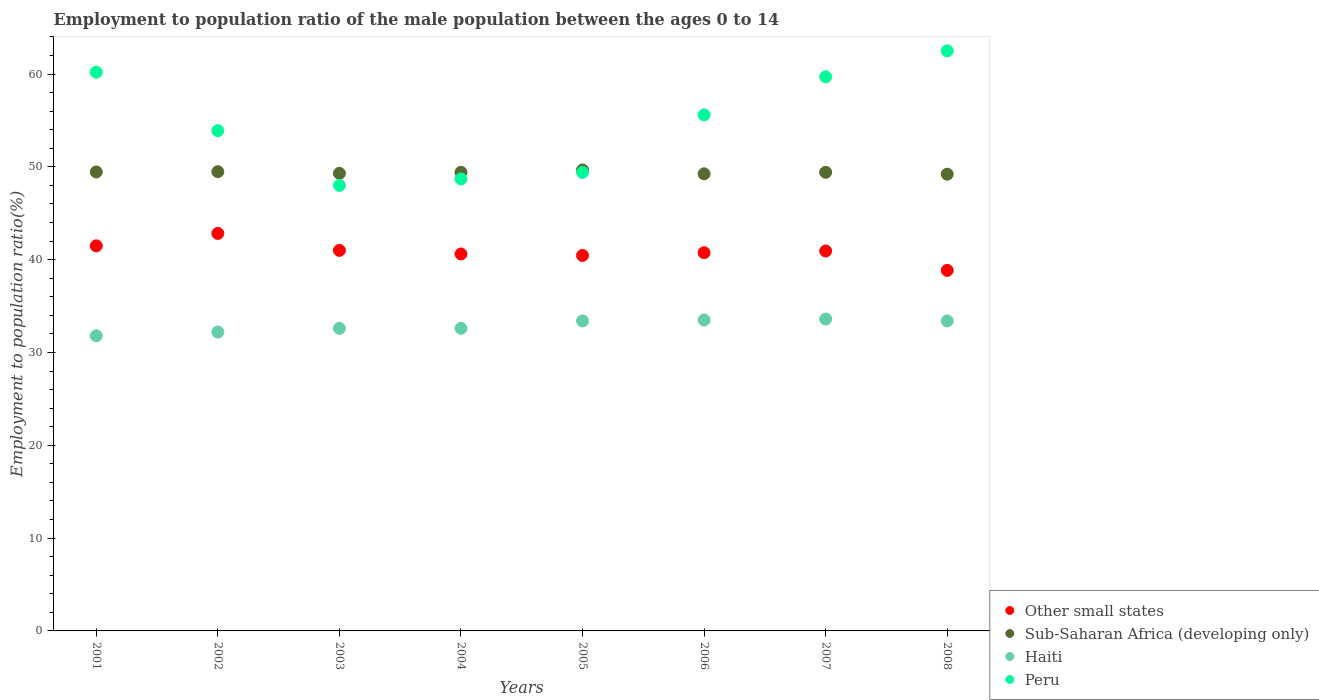What is the employment to population ratio in Other small states in 2008?
Your response must be concise. 38.85. Across all years, what is the maximum employment to population ratio in Haiti?
Your response must be concise. 33.6. Across all years, what is the minimum employment to population ratio in Haiti?
Ensure brevity in your answer.  31.8. In which year was the employment to population ratio in Haiti minimum?
Give a very brief answer. 2001. What is the total employment to population ratio in Haiti in the graph?
Provide a short and direct response. 263.1. What is the difference between the employment to population ratio in Peru in 2003 and that in 2004?
Ensure brevity in your answer.  -0.7. What is the difference between the employment to population ratio in Peru in 2006 and the employment to population ratio in Sub-Saharan Africa (developing only) in 2008?
Make the answer very short. 6.39. What is the average employment to population ratio in Other small states per year?
Provide a succinct answer. 40.86. In the year 2002, what is the difference between the employment to population ratio in Other small states and employment to population ratio in Peru?
Provide a succinct answer. -11.07. In how many years, is the employment to population ratio in Haiti greater than 48 %?
Make the answer very short. 0. Is the employment to population ratio in Haiti in 2007 less than that in 2008?
Give a very brief answer. No. Is the difference between the employment to population ratio in Other small states in 2004 and 2007 greater than the difference between the employment to population ratio in Peru in 2004 and 2007?
Ensure brevity in your answer.  Yes. What is the difference between the highest and the second highest employment to population ratio in Haiti?
Provide a succinct answer. 0.1. What is the difference between the highest and the lowest employment to population ratio in Other small states?
Your answer should be compact. 3.98. In how many years, is the employment to population ratio in Other small states greater than the average employment to population ratio in Other small states taken over all years?
Offer a very short reply. 4. Is it the case that in every year, the sum of the employment to population ratio in Haiti and employment to population ratio in Other small states  is greater than the employment to population ratio in Peru?
Your answer should be compact. Yes. Is the employment to population ratio in Sub-Saharan Africa (developing only) strictly less than the employment to population ratio in Peru over the years?
Give a very brief answer. No. How many years are there in the graph?
Your answer should be very brief. 8. What is the difference between two consecutive major ticks on the Y-axis?
Your answer should be compact. 10. Does the graph contain grids?
Your response must be concise. No. Where does the legend appear in the graph?
Offer a terse response. Bottom right. How are the legend labels stacked?
Offer a very short reply. Vertical. What is the title of the graph?
Give a very brief answer. Employment to population ratio of the male population between the ages 0 to 14. What is the Employment to population ratio(%) in Other small states in 2001?
Keep it short and to the point. 41.49. What is the Employment to population ratio(%) in Sub-Saharan Africa (developing only) in 2001?
Offer a very short reply. 49.45. What is the Employment to population ratio(%) in Haiti in 2001?
Provide a succinct answer. 31.8. What is the Employment to population ratio(%) of Peru in 2001?
Provide a short and direct response. 60.2. What is the Employment to population ratio(%) in Other small states in 2002?
Provide a short and direct response. 42.83. What is the Employment to population ratio(%) in Sub-Saharan Africa (developing only) in 2002?
Provide a short and direct response. 49.48. What is the Employment to population ratio(%) in Haiti in 2002?
Offer a very short reply. 32.2. What is the Employment to population ratio(%) of Peru in 2002?
Give a very brief answer. 53.9. What is the Employment to population ratio(%) of Other small states in 2003?
Provide a succinct answer. 41. What is the Employment to population ratio(%) in Sub-Saharan Africa (developing only) in 2003?
Offer a terse response. 49.3. What is the Employment to population ratio(%) in Haiti in 2003?
Your answer should be compact. 32.6. What is the Employment to population ratio(%) of Peru in 2003?
Your response must be concise. 48. What is the Employment to population ratio(%) of Other small states in 2004?
Your answer should be very brief. 40.61. What is the Employment to population ratio(%) in Sub-Saharan Africa (developing only) in 2004?
Offer a very short reply. 49.41. What is the Employment to population ratio(%) of Haiti in 2004?
Your answer should be very brief. 32.6. What is the Employment to population ratio(%) of Peru in 2004?
Offer a very short reply. 48.7. What is the Employment to population ratio(%) in Other small states in 2005?
Keep it short and to the point. 40.45. What is the Employment to population ratio(%) of Sub-Saharan Africa (developing only) in 2005?
Keep it short and to the point. 49.66. What is the Employment to population ratio(%) of Haiti in 2005?
Give a very brief answer. 33.4. What is the Employment to population ratio(%) of Peru in 2005?
Your response must be concise. 49.4. What is the Employment to population ratio(%) of Other small states in 2006?
Ensure brevity in your answer.  40.75. What is the Employment to population ratio(%) in Sub-Saharan Africa (developing only) in 2006?
Provide a succinct answer. 49.25. What is the Employment to population ratio(%) of Haiti in 2006?
Ensure brevity in your answer.  33.5. What is the Employment to population ratio(%) of Peru in 2006?
Your response must be concise. 55.6. What is the Employment to population ratio(%) of Other small states in 2007?
Make the answer very short. 40.93. What is the Employment to population ratio(%) in Sub-Saharan Africa (developing only) in 2007?
Your answer should be compact. 49.41. What is the Employment to population ratio(%) of Haiti in 2007?
Your response must be concise. 33.6. What is the Employment to population ratio(%) in Peru in 2007?
Give a very brief answer. 59.7. What is the Employment to population ratio(%) in Other small states in 2008?
Make the answer very short. 38.85. What is the Employment to population ratio(%) of Sub-Saharan Africa (developing only) in 2008?
Offer a terse response. 49.21. What is the Employment to population ratio(%) in Haiti in 2008?
Offer a terse response. 33.4. What is the Employment to population ratio(%) of Peru in 2008?
Provide a succinct answer. 62.5. Across all years, what is the maximum Employment to population ratio(%) in Other small states?
Make the answer very short. 42.83. Across all years, what is the maximum Employment to population ratio(%) in Sub-Saharan Africa (developing only)?
Make the answer very short. 49.66. Across all years, what is the maximum Employment to population ratio(%) of Haiti?
Offer a terse response. 33.6. Across all years, what is the maximum Employment to population ratio(%) of Peru?
Provide a short and direct response. 62.5. Across all years, what is the minimum Employment to population ratio(%) in Other small states?
Keep it short and to the point. 38.85. Across all years, what is the minimum Employment to population ratio(%) of Sub-Saharan Africa (developing only)?
Give a very brief answer. 49.21. Across all years, what is the minimum Employment to population ratio(%) of Haiti?
Your response must be concise. 31.8. Across all years, what is the minimum Employment to population ratio(%) of Peru?
Provide a succinct answer. 48. What is the total Employment to population ratio(%) in Other small states in the graph?
Keep it short and to the point. 326.91. What is the total Employment to population ratio(%) of Sub-Saharan Africa (developing only) in the graph?
Keep it short and to the point. 395.16. What is the total Employment to population ratio(%) of Haiti in the graph?
Make the answer very short. 263.1. What is the total Employment to population ratio(%) of Peru in the graph?
Offer a terse response. 438. What is the difference between the Employment to population ratio(%) in Other small states in 2001 and that in 2002?
Give a very brief answer. -1.34. What is the difference between the Employment to population ratio(%) of Sub-Saharan Africa (developing only) in 2001 and that in 2002?
Offer a very short reply. -0.03. What is the difference between the Employment to population ratio(%) of Haiti in 2001 and that in 2002?
Keep it short and to the point. -0.4. What is the difference between the Employment to population ratio(%) in Peru in 2001 and that in 2002?
Ensure brevity in your answer.  6.3. What is the difference between the Employment to population ratio(%) in Other small states in 2001 and that in 2003?
Give a very brief answer. 0.49. What is the difference between the Employment to population ratio(%) of Sub-Saharan Africa (developing only) in 2001 and that in 2003?
Offer a very short reply. 0.15. What is the difference between the Employment to population ratio(%) in Peru in 2001 and that in 2003?
Keep it short and to the point. 12.2. What is the difference between the Employment to population ratio(%) in Other small states in 2001 and that in 2004?
Give a very brief answer. 0.87. What is the difference between the Employment to population ratio(%) in Sub-Saharan Africa (developing only) in 2001 and that in 2004?
Offer a very short reply. 0.04. What is the difference between the Employment to population ratio(%) of Haiti in 2001 and that in 2004?
Make the answer very short. -0.8. What is the difference between the Employment to population ratio(%) of Peru in 2001 and that in 2004?
Your answer should be very brief. 11.5. What is the difference between the Employment to population ratio(%) in Other small states in 2001 and that in 2005?
Offer a very short reply. 1.03. What is the difference between the Employment to population ratio(%) of Sub-Saharan Africa (developing only) in 2001 and that in 2005?
Your answer should be very brief. -0.21. What is the difference between the Employment to population ratio(%) in Peru in 2001 and that in 2005?
Ensure brevity in your answer.  10.8. What is the difference between the Employment to population ratio(%) in Other small states in 2001 and that in 2006?
Provide a short and direct response. 0.74. What is the difference between the Employment to population ratio(%) of Sub-Saharan Africa (developing only) in 2001 and that in 2006?
Your answer should be very brief. 0.2. What is the difference between the Employment to population ratio(%) of Other small states in 2001 and that in 2007?
Provide a short and direct response. 0.55. What is the difference between the Employment to population ratio(%) in Sub-Saharan Africa (developing only) in 2001 and that in 2007?
Provide a short and direct response. 0.04. What is the difference between the Employment to population ratio(%) in Haiti in 2001 and that in 2007?
Keep it short and to the point. -1.8. What is the difference between the Employment to population ratio(%) of Other small states in 2001 and that in 2008?
Your answer should be very brief. 2.64. What is the difference between the Employment to population ratio(%) in Sub-Saharan Africa (developing only) in 2001 and that in 2008?
Keep it short and to the point. 0.24. What is the difference between the Employment to population ratio(%) of Haiti in 2001 and that in 2008?
Give a very brief answer. -1.6. What is the difference between the Employment to population ratio(%) in Peru in 2001 and that in 2008?
Your answer should be very brief. -2.3. What is the difference between the Employment to population ratio(%) in Other small states in 2002 and that in 2003?
Keep it short and to the point. 1.83. What is the difference between the Employment to population ratio(%) in Sub-Saharan Africa (developing only) in 2002 and that in 2003?
Your response must be concise. 0.18. What is the difference between the Employment to population ratio(%) in Other small states in 2002 and that in 2004?
Your answer should be very brief. 2.21. What is the difference between the Employment to population ratio(%) in Sub-Saharan Africa (developing only) in 2002 and that in 2004?
Provide a short and direct response. 0.07. What is the difference between the Employment to population ratio(%) in Haiti in 2002 and that in 2004?
Provide a succinct answer. -0.4. What is the difference between the Employment to population ratio(%) in Other small states in 2002 and that in 2005?
Provide a short and direct response. 2.37. What is the difference between the Employment to population ratio(%) of Sub-Saharan Africa (developing only) in 2002 and that in 2005?
Your answer should be very brief. -0.18. What is the difference between the Employment to population ratio(%) in Other small states in 2002 and that in 2006?
Your answer should be compact. 2.08. What is the difference between the Employment to population ratio(%) of Sub-Saharan Africa (developing only) in 2002 and that in 2006?
Ensure brevity in your answer.  0.23. What is the difference between the Employment to population ratio(%) of Haiti in 2002 and that in 2006?
Ensure brevity in your answer.  -1.3. What is the difference between the Employment to population ratio(%) of Other small states in 2002 and that in 2007?
Make the answer very short. 1.89. What is the difference between the Employment to population ratio(%) of Sub-Saharan Africa (developing only) in 2002 and that in 2007?
Your answer should be very brief. 0.07. What is the difference between the Employment to population ratio(%) of Other small states in 2002 and that in 2008?
Keep it short and to the point. 3.98. What is the difference between the Employment to population ratio(%) of Sub-Saharan Africa (developing only) in 2002 and that in 2008?
Offer a very short reply. 0.27. What is the difference between the Employment to population ratio(%) of Haiti in 2002 and that in 2008?
Your answer should be compact. -1.2. What is the difference between the Employment to population ratio(%) in Peru in 2002 and that in 2008?
Your answer should be compact. -8.6. What is the difference between the Employment to population ratio(%) in Other small states in 2003 and that in 2004?
Offer a very short reply. 0.38. What is the difference between the Employment to population ratio(%) of Sub-Saharan Africa (developing only) in 2003 and that in 2004?
Make the answer very short. -0.11. What is the difference between the Employment to population ratio(%) in Other small states in 2003 and that in 2005?
Ensure brevity in your answer.  0.54. What is the difference between the Employment to population ratio(%) of Sub-Saharan Africa (developing only) in 2003 and that in 2005?
Offer a terse response. -0.36. What is the difference between the Employment to population ratio(%) of Other small states in 2003 and that in 2006?
Offer a very short reply. 0.25. What is the difference between the Employment to population ratio(%) in Sub-Saharan Africa (developing only) in 2003 and that in 2006?
Provide a short and direct response. 0.05. What is the difference between the Employment to population ratio(%) of Other small states in 2003 and that in 2007?
Offer a terse response. 0.06. What is the difference between the Employment to population ratio(%) of Sub-Saharan Africa (developing only) in 2003 and that in 2007?
Provide a short and direct response. -0.11. What is the difference between the Employment to population ratio(%) of Other small states in 2003 and that in 2008?
Your answer should be very brief. 2.15. What is the difference between the Employment to population ratio(%) of Sub-Saharan Africa (developing only) in 2003 and that in 2008?
Your answer should be compact. 0.09. What is the difference between the Employment to population ratio(%) of Peru in 2003 and that in 2008?
Provide a succinct answer. -14.5. What is the difference between the Employment to population ratio(%) of Other small states in 2004 and that in 2005?
Make the answer very short. 0.16. What is the difference between the Employment to population ratio(%) in Sub-Saharan Africa (developing only) in 2004 and that in 2005?
Provide a succinct answer. -0.25. What is the difference between the Employment to population ratio(%) in Peru in 2004 and that in 2005?
Your response must be concise. -0.7. What is the difference between the Employment to population ratio(%) of Other small states in 2004 and that in 2006?
Offer a very short reply. -0.14. What is the difference between the Employment to population ratio(%) of Sub-Saharan Africa (developing only) in 2004 and that in 2006?
Give a very brief answer. 0.16. What is the difference between the Employment to population ratio(%) in Other small states in 2004 and that in 2007?
Ensure brevity in your answer.  -0.32. What is the difference between the Employment to population ratio(%) of Sub-Saharan Africa (developing only) in 2004 and that in 2007?
Your response must be concise. 0. What is the difference between the Employment to population ratio(%) of Peru in 2004 and that in 2007?
Provide a succinct answer. -11. What is the difference between the Employment to population ratio(%) in Other small states in 2004 and that in 2008?
Ensure brevity in your answer.  1.77. What is the difference between the Employment to population ratio(%) of Sub-Saharan Africa (developing only) in 2004 and that in 2008?
Provide a short and direct response. 0.2. What is the difference between the Employment to population ratio(%) in Other small states in 2005 and that in 2006?
Give a very brief answer. -0.3. What is the difference between the Employment to population ratio(%) of Sub-Saharan Africa (developing only) in 2005 and that in 2006?
Keep it short and to the point. 0.41. What is the difference between the Employment to population ratio(%) of Other small states in 2005 and that in 2007?
Your answer should be compact. -0.48. What is the difference between the Employment to population ratio(%) of Sub-Saharan Africa (developing only) in 2005 and that in 2007?
Your answer should be very brief. 0.25. What is the difference between the Employment to population ratio(%) in Other small states in 2005 and that in 2008?
Provide a short and direct response. 1.61. What is the difference between the Employment to population ratio(%) in Sub-Saharan Africa (developing only) in 2005 and that in 2008?
Your answer should be very brief. 0.45. What is the difference between the Employment to population ratio(%) of Haiti in 2005 and that in 2008?
Offer a terse response. 0. What is the difference between the Employment to population ratio(%) in Peru in 2005 and that in 2008?
Ensure brevity in your answer.  -13.1. What is the difference between the Employment to population ratio(%) of Other small states in 2006 and that in 2007?
Your answer should be very brief. -0.18. What is the difference between the Employment to population ratio(%) of Sub-Saharan Africa (developing only) in 2006 and that in 2007?
Your answer should be compact. -0.16. What is the difference between the Employment to population ratio(%) in Haiti in 2006 and that in 2007?
Ensure brevity in your answer.  -0.1. What is the difference between the Employment to population ratio(%) in Other small states in 2006 and that in 2008?
Offer a terse response. 1.91. What is the difference between the Employment to population ratio(%) of Sub-Saharan Africa (developing only) in 2006 and that in 2008?
Make the answer very short. 0.04. What is the difference between the Employment to population ratio(%) in Other small states in 2007 and that in 2008?
Your answer should be compact. 2.09. What is the difference between the Employment to population ratio(%) of Sub-Saharan Africa (developing only) in 2007 and that in 2008?
Your response must be concise. 0.2. What is the difference between the Employment to population ratio(%) of Other small states in 2001 and the Employment to population ratio(%) of Sub-Saharan Africa (developing only) in 2002?
Provide a succinct answer. -7.99. What is the difference between the Employment to population ratio(%) in Other small states in 2001 and the Employment to population ratio(%) in Haiti in 2002?
Give a very brief answer. 9.29. What is the difference between the Employment to population ratio(%) of Other small states in 2001 and the Employment to population ratio(%) of Peru in 2002?
Make the answer very short. -12.41. What is the difference between the Employment to population ratio(%) of Sub-Saharan Africa (developing only) in 2001 and the Employment to population ratio(%) of Haiti in 2002?
Offer a terse response. 17.25. What is the difference between the Employment to population ratio(%) of Sub-Saharan Africa (developing only) in 2001 and the Employment to population ratio(%) of Peru in 2002?
Offer a terse response. -4.45. What is the difference between the Employment to population ratio(%) of Haiti in 2001 and the Employment to population ratio(%) of Peru in 2002?
Your answer should be compact. -22.1. What is the difference between the Employment to population ratio(%) of Other small states in 2001 and the Employment to population ratio(%) of Sub-Saharan Africa (developing only) in 2003?
Make the answer very short. -7.81. What is the difference between the Employment to population ratio(%) of Other small states in 2001 and the Employment to population ratio(%) of Haiti in 2003?
Offer a very short reply. 8.89. What is the difference between the Employment to population ratio(%) in Other small states in 2001 and the Employment to population ratio(%) in Peru in 2003?
Provide a succinct answer. -6.51. What is the difference between the Employment to population ratio(%) in Sub-Saharan Africa (developing only) in 2001 and the Employment to population ratio(%) in Haiti in 2003?
Provide a short and direct response. 16.85. What is the difference between the Employment to population ratio(%) of Sub-Saharan Africa (developing only) in 2001 and the Employment to population ratio(%) of Peru in 2003?
Keep it short and to the point. 1.45. What is the difference between the Employment to population ratio(%) of Haiti in 2001 and the Employment to population ratio(%) of Peru in 2003?
Ensure brevity in your answer.  -16.2. What is the difference between the Employment to population ratio(%) in Other small states in 2001 and the Employment to population ratio(%) in Sub-Saharan Africa (developing only) in 2004?
Offer a very short reply. -7.92. What is the difference between the Employment to population ratio(%) in Other small states in 2001 and the Employment to population ratio(%) in Haiti in 2004?
Your response must be concise. 8.89. What is the difference between the Employment to population ratio(%) of Other small states in 2001 and the Employment to population ratio(%) of Peru in 2004?
Keep it short and to the point. -7.21. What is the difference between the Employment to population ratio(%) of Sub-Saharan Africa (developing only) in 2001 and the Employment to population ratio(%) of Haiti in 2004?
Your answer should be compact. 16.85. What is the difference between the Employment to population ratio(%) in Sub-Saharan Africa (developing only) in 2001 and the Employment to population ratio(%) in Peru in 2004?
Your response must be concise. 0.75. What is the difference between the Employment to population ratio(%) in Haiti in 2001 and the Employment to population ratio(%) in Peru in 2004?
Ensure brevity in your answer.  -16.9. What is the difference between the Employment to population ratio(%) of Other small states in 2001 and the Employment to population ratio(%) of Sub-Saharan Africa (developing only) in 2005?
Provide a succinct answer. -8.17. What is the difference between the Employment to population ratio(%) of Other small states in 2001 and the Employment to population ratio(%) of Haiti in 2005?
Give a very brief answer. 8.09. What is the difference between the Employment to population ratio(%) in Other small states in 2001 and the Employment to population ratio(%) in Peru in 2005?
Provide a succinct answer. -7.91. What is the difference between the Employment to population ratio(%) of Sub-Saharan Africa (developing only) in 2001 and the Employment to population ratio(%) of Haiti in 2005?
Your answer should be compact. 16.05. What is the difference between the Employment to population ratio(%) of Sub-Saharan Africa (developing only) in 2001 and the Employment to population ratio(%) of Peru in 2005?
Your answer should be very brief. 0.05. What is the difference between the Employment to population ratio(%) in Haiti in 2001 and the Employment to population ratio(%) in Peru in 2005?
Offer a very short reply. -17.6. What is the difference between the Employment to population ratio(%) of Other small states in 2001 and the Employment to population ratio(%) of Sub-Saharan Africa (developing only) in 2006?
Provide a succinct answer. -7.76. What is the difference between the Employment to population ratio(%) in Other small states in 2001 and the Employment to population ratio(%) in Haiti in 2006?
Make the answer very short. 7.99. What is the difference between the Employment to population ratio(%) in Other small states in 2001 and the Employment to population ratio(%) in Peru in 2006?
Provide a succinct answer. -14.11. What is the difference between the Employment to population ratio(%) in Sub-Saharan Africa (developing only) in 2001 and the Employment to population ratio(%) in Haiti in 2006?
Your answer should be compact. 15.95. What is the difference between the Employment to population ratio(%) in Sub-Saharan Africa (developing only) in 2001 and the Employment to population ratio(%) in Peru in 2006?
Your answer should be compact. -6.15. What is the difference between the Employment to population ratio(%) in Haiti in 2001 and the Employment to population ratio(%) in Peru in 2006?
Ensure brevity in your answer.  -23.8. What is the difference between the Employment to population ratio(%) in Other small states in 2001 and the Employment to population ratio(%) in Sub-Saharan Africa (developing only) in 2007?
Give a very brief answer. -7.92. What is the difference between the Employment to population ratio(%) of Other small states in 2001 and the Employment to population ratio(%) of Haiti in 2007?
Keep it short and to the point. 7.89. What is the difference between the Employment to population ratio(%) of Other small states in 2001 and the Employment to population ratio(%) of Peru in 2007?
Your answer should be compact. -18.21. What is the difference between the Employment to population ratio(%) of Sub-Saharan Africa (developing only) in 2001 and the Employment to population ratio(%) of Haiti in 2007?
Keep it short and to the point. 15.85. What is the difference between the Employment to population ratio(%) in Sub-Saharan Africa (developing only) in 2001 and the Employment to population ratio(%) in Peru in 2007?
Provide a succinct answer. -10.25. What is the difference between the Employment to population ratio(%) in Haiti in 2001 and the Employment to population ratio(%) in Peru in 2007?
Offer a very short reply. -27.9. What is the difference between the Employment to population ratio(%) in Other small states in 2001 and the Employment to population ratio(%) in Sub-Saharan Africa (developing only) in 2008?
Provide a succinct answer. -7.72. What is the difference between the Employment to population ratio(%) in Other small states in 2001 and the Employment to population ratio(%) in Haiti in 2008?
Ensure brevity in your answer.  8.09. What is the difference between the Employment to population ratio(%) of Other small states in 2001 and the Employment to population ratio(%) of Peru in 2008?
Provide a succinct answer. -21.01. What is the difference between the Employment to population ratio(%) of Sub-Saharan Africa (developing only) in 2001 and the Employment to population ratio(%) of Haiti in 2008?
Provide a short and direct response. 16.05. What is the difference between the Employment to population ratio(%) of Sub-Saharan Africa (developing only) in 2001 and the Employment to population ratio(%) of Peru in 2008?
Offer a very short reply. -13.05. What is the difference between the Employment to population ratio(%) of Haiti in 2001 and the Employment to population ratio(%) of Peru in 2008?
Offer a very short reply. -30.7. What is the difference between the Employment to population ratio(%) in Other small states in 2002 and the Employment to population ratio(%) in Sub-Saharan Africa (developing only) in 2003?
Your answer should be compact. -6.47. What is the difference between the Employment to population ratio(%) in Other small states in 2002 and the Employment to population ratio(%) in Haiti in 2003?
Ensure brevity in your answer.  10.23. What is the difference between the Employment to population ratio(%) in Other small states in 2002 and the Employment to population ratio(%) in Peru in 2003?
Provide a short and direct response. -5.17. What is the difference between the Employment to population ratio(%) in Sub-Saharan Africa (developing only) in 2002 and the Employment to population ratio(%) in Haiti in 2003?
Your answer should be compact. 16.88. What is the difference between the Employment to population ratio(%) of Sub-Saharan Africa (developing only) in 2002 and the Employment to population ratio(%) of Peru in 2003?
Provide a short and direct response. 1.48. What is the difference between the Employment to population ratio(%) of Haiti in 2002 and the Employment to population ratio(%) of Peru in 2003?
Provide a short and direct response. -15.8. What is the difference between the Employment to population ratio(%) of Other small states in 2002 and the Employment to population ratio(%) of Sub-Saharan Africa (developing only) in 2004?
Provide a succinct answer. -6.58. What is the difference between the Employment to population ratio(%) of Other small states in 2002 and the Employment to population ratio(%) of Haiti in 2004?
Make the answer very short. 10.23. What is the difference between the Employment to population ratio(%) in Other small states in 2002 and the Employment to population ratio(%) in Peru in 2004?
Offer a terse response. -5.87. What is the difference between the Employment to population ratio(%) in Sub-Saharan Africa (developing only) in 2002 and the Employment to population ratio(%) in Haiti in 2004?
Offer a terse response. 16.88. What is the difference between the Employment to population ratio(%) of Sub-Saharan Africa (developing only) in 2002 and the Employment to population ratio(%) of Peru in 2004?
Give a very brief answer. 0.78. What is the difference between the Employment to population ratio(%) of Haiti in 2002 and the Employment to population ratio(%) of Peru in 2004?
Give a very brief answer. -16.5. What is the difference between the Employment to population ratio(%) in Other small states in 2002 and the Employment to population ratio(%) in Sub-Saharan Africa (developing only) in 2005?
Give a very brief answer. -6.83. What is the difference between the Employment to population ratio(%) in Other small states in 2002 and the Employment to population ratio(%) in Haiti in 2005?
Offer a terse response. 9.43. What is the difference between the Employment to population ratio(%) of Other small states in 2002 and the Employment to population ratio(%) of Peru in 2005?
Provide a succinct answer. -6.57. What is the difference between the Employment to population ratio(%) in Sub-Saharan Africa (developing only) in 2002 and the Employment to population ratio(%) in Haiti in 2005?
Offer a terse response. 16.08. What is the difference between the Employment to population ratio(%) of Sub-Saharan Africa (developing only) in 2002 and the Employment to population ratio(%) of Peru in 2005?
Give a very brief answer. 0.08. What is the difference between the Employment to population ratio(%) in Haiti in 2002 and the Employment to population ratio(%) in Peru in 2005?
Your answer should be compact. -17.2. What is the difference between the Employment to population ratio(%) of Other small states in 2002 and the Employment to population ratio(%) of Sub-Saharan Africa (developing only) in 2006?
Provide a short and direct response. -6.42. What is the difference between the Employment to population ratio(%) of Other small states in 2002 and the Employment to population ratio(%) of Haiti in 2006?
Make the answer very short. 9.33. What is the difference between the Employment to population ratio(%) of Other small states in 2002 and the Employment to population ratio(%) of Peru in 2006?
Your answer should be very brief. -12.77. What is the difference between the Employment to population ratio(%) in Sub-Saharan Africa (developing only) in 2002 and the Employment to population ratio(%) in Haiti in 2006?
Provide a short and direct response. 15.98. What is the difference between the Employment to population ratio(%) in Sub-Saharan Africa (developing only) in 2002 and the Employment to population ratio(%) in Peru in 2006?
Offer a terse response. -6.12. What is the difference between the Employment to population ratio(%) in Haiti in 2002 and the Employment to population ratio(%) in Peru in 2006?
Your answer should be very brief. -23.4. What is the difference between the Employment to population ratio(%) in Other small states in 2002 and the Employment to population ratio(%) in Sub-Saharan Africa (developing only) in 2007?
Your answer should be very brief. -6.58. What is the difference between the Employment to population ratio(%) in Other small states in 2002 and the Employment to population ratio(%) in Haiti in 2007?
Make the answer very short. 9.23. What is the difference between the Employment to population ratio(%) of Other small states in 2002 and the Employment to population ratio(%) of Peru in 2007?
Offer a terse response. -16.87. What is the difference between the Employment to population ratio(%) in Sub-Saharan Africa (developing only) in 2002 and the Employment to population ratio(%) in Haiti in 2007?
Ensure brevity in your answer.  15.88. What is the difference between the Employment to population ratio(%) of Sub-Saharan Africa (developing only) in 2002 and the Employment to population ratio(%) of Peru in 2007?
Give a very brief answer. -10.22. What is the difference between the Employment to population ratio(%) of Haiti in 2002 and the Employment to population ratio(%) of Peru in 2007?
Offer a terse response. -27.5. What is the difference between the Employment to population ratio(%) in Other small states in 2002 and the Employment to population ratio(%) in Sub-Saharan Africa (developing only) in 2008?
Provide a succinct answer. -6.38. What is the difference between the Employment to population ratio(%) in Other small states in 2002 and the Employment to population ratio(%) in Haiti in 2008?
Provide a short and direct response. 9.43. What is the difference between the Employment to population ratio(%) of Other small states in 2002 and the Employment to population ratio(%) of Peru in 2008?
Provide a succinct answer. -19.67. What is the difference between the Employment to population ratio(%) in Sub-Saharan Africa (developing only) in 2002 and the Employment to population ratio(%) in Haiti in 2008?
Provide a succinct answer. 16.08. What is the difference between the Employment to population ratio(%) in Sub-Saharan Africa (developing only) in 2002 and the Employment to population ratio(%) in Peru in 2008?
Your response must be concise. -13.02. What is the difference between the Employment to population ratio(%) of Haiti in 2002 and the Employment to population ratio(%) of Peru in 2008?
Provide a succinct answer. -30.3. What is the difference between the Employment to population ratio(%) in Other small states in 2003 and the Employment to population ratio(%) in Sub-Saharan Africa (developing only) in 2004?
Your answer should be very brief. -8.41. What is the difference between the Employment to population ratio(%) in Other small states in 2003 and the Employment to population ratio(%) in Haiti in 2004?
Your response must be concise. 8.4. What is the difference between the Employment to population ratio(%) of Other small states in 2003 and the Employment to population ratio(%) of Peru in 2004?
Provide a short and direct response. -7.7. What is the difference between the Employment to population ratio(%) of Sub-Saharan Africa (developing only) in 2003 and the Employment to population ratio(%) of Haiti in 2004?
Ensure brevity in your answer.  16.7. What is the difference between the Employment to population ratio(%) in Sub-Saharan Africa (developing only) in 2003 and the Employment to population ratio(%) in Peru in 2004?
Provide a short and direct response. 0.6. What is the difference between the Employment to population ratio(%) in Haiti in 2003 and the Employment to population ratio(%) in Peru in 2004?
Your answer should be very brief. -16.1. What is the difference between the Employment to population ratio(%) of Other small states in 2003 and the Employment to population ratio(%) of Sub-Saharan Africa (developing only) in 2005?
Ensure brevity in your answer.  -8.66. What is the difference between the Employment to population ratio(%) in Other small states in 2003 and the Employment to population ratio(%) in Haiti in 2005?
Provide a short and direct response. 7.6. What is the difference between the Employment to population ratio(%) in Other small states in 2003 and the Employment to population ratio(%) in Peru in 2005?
Make the answer very short. -8.4. What is the difference between the Employment to population ratio(%) in Sub-Saharan Africa (developing only) in 2003 and the Employment to population ratio(%) in Haiti in 2005?
Your response must be concise. 15.9. What is the difference between the Employment to population ratio(%) of Sub-Saharan Africa (developing only) in 2003 and the Employment to population ratio(%) of Peru in 2005?
Offer a very short reply. -0.1. What is the difference between the Employment to population ratio(%) of Haiti in 2003 and the Employment to population ratio(%) of Peru in 2005?
Your answer should be very brief. -16.8. What is the difference between the Employment to population ratio(%) of Other small states in 2003 and the Employment to population ratio(%) of Sub-Saharan Africa (developing only) in 2006?
Give a very brief answer. -8.25. What is the difference between the Employment to population ratio(%) in Other small states in 2003 and the Employment to population ratio(%) in Haiti in 2006?
Offer a very short reply. 7.5. What is the difference between the Employment to population ratio(%) of Other small states in 2003 and the Employment to population ratio(%) of Peru in 2006?
Provide a short and direct response. -14.6. What is the difference between the Employment to population ratio(%) in Sub-Saharan Africa (developing only) in 2003 and the Employment to population ratio(%) in Haiti in 2006?
Offer a very short reply. 15.8. What is the difference between the Employment to population ratio(%) in Sub-Saharan Africa (developing only) in 2003 and the Employment to population ratio(%) in Peru in 2006?
Your answer should be compact. -6.3. What is the difference between the Employment to population ratio(%) in Other small states in 2003 and the Employment to population ratio(%) in Sub-Saharan Africa (developing only) in 2007?
Your answer should be compact. -8.41. What is the difference between the Employment to population ratio(%) in Other small states in 2003 and the Employment to population ratio(%) in Haiti in 2007?
Offer a very short reply. 7.4. What is the difference between the Employment to population ratio(%) in Other small states in 2003 and the Employment to population ratio(%) in Peru in 2007?
Keep it short and to the point. -18.7. What is the difference between the Employment to population ratio(%) in Sub-Saharan Africa (developing only) in 2003 and the Employment to population ratio(%) in Haiti in 2007?
Give a very brief answer. 15.7. What is the difference between the Employment to population ratio(%) in Sub-Saharan Africa (developing only) in 2003 and the Employment to population ratio(%) in Peru in 2007?
Provide a short and direct response. -10.4. What is the difference between the Employment to population ratio(%) in Haiti in 2003 and the Employment to population ratio(%) in Peru in 2007?
Make the answer very short. -27.1. What is the difference between the Employment to population ratio(%) of Other small states in 2003 and the Employment to population ratio(%) of Sub-Saharan Africa (developing only) in 2008?
Ensure brevity in your answer.  -8.21. What is the difference between the Employment to population ratio(%) in Other small states in 2003 and the Employment to population ratio(%) in Haiti in 2008?
Give a very brief answer. 7.6. What is the difference between the Employment to population ratio(%) of Other small states in 2003 and the Employment to population ratio(%) of Peru in 2008?
Offer a very short reply. -21.5. What is the difference between the Employment to population ratio(%) in Sub-Saharan Africa (developing only) in 2003 and the Employment to population ratio(%) in Haiti in 2008?
Ensure brevity in your answer.  15.9. What is the difference between the Employment to population ratio(%) in Sub-Saharan Africa (developing only) in 2003 and the Employment to population ratio(%) in Peru in 2008?
Provide a succinct answer. -13.2. What is the difference between the Employment to population ratio(%) of Haiti in 2003 and the Employment to population ratio(%) of Peru in 2008?
Provide a succinct answer. -29.9. What is the difference between the Employment to population ratio(%) in Other small states in 2004 and the Employment to population ratio(%) in Sub-Saharan Africa (developing only) in 2005?
Your answer should be very brief. -9.04. What is the difference between the Employment to population ratio(%) of Other small states in 2004 and the Employment to population ratio(%) of Haiti in 2005?
Provide a succinct answer. 7.21. What is the difference between the Employment to population ratio(%) in Other small states in 2004 and the Employment to population ratio(%) in Peru in 2005?
Keep it short and to the point. -8.79. What is the difference between the Employment to population ratio(%) of Sub-Saharan Africa (developing only) in 2004 and the Employment to population ratio(%) of Haiti in 2005?
Provide a succinct answer. 16.01. What is the difference between the Employment to population ratio(%) of Sub-Saharan Africa (developing only) in 2004 and the Employment to population ratio(%) of Peru in 2005?
Make the answer very short. 0.01. What is the difference between the Employment to population ratio(%) of Haiti in 2004 and the Employment to population ratio(%) of Peru in 2005?
Your answer should be very brief. -16.8. What is the difference between the Employment to population ratio(%) in Other small states in 2004 and the Employment to population ratio(%) in Sub-Saharan Africa (developing only) in 2006?
Keep it short and to the point. -8.63. What is the difference between the Employment to population ratio(%) of Other small states in 2004 and the Employment to population ratio(%) of Haiti in 2006?
Your answer should be very brief. 7.11. What is the difference between the Employment to population ratio(%) in Other small states in 2004 and the Employment to population ratio(%) in Peru in 2006?
Provide a succinct answer. -14.99. What is the difference between the Employment to population ratio(%) of Sub-Saharan Africa (developing only) in 2004 and the Employment to population ratio(%) of Haiti in 2006?
Make the answer very short. 15.91. What is the difference between the Employment to population ratio(%) in Sub-Saharan Africa (developing only) in 2004 and the Employment to population ratio(%) in Peru in 2006?
Give a very brief answer. -6.19. What is the difference between the Employment to population ratio(%) of Other small states in 2004 and the Employment to population ratio(%) of Sub-Saharan Africa (developing only) in 2007?
Offer a terse response. -8.79. What is the difference between the Employment to population ratio(%) in Other small states in 2004 and the Employment to population ratio(%) in Haiti in 2007?
Provide a short and direct response. 7.01. What is the difference between the Employment to population ratio(%) of Other small states in 2004 and the Employment to population ratio(%) of Peru in 2007?
Your response must be concise. -19.09. What is the difference between the Employment to population ratio(%) of Sub-Saharan Africa (developing only) in 2004 and the Employment to population ratio(%) of Haiti in 2007?
Make the answer very short. 15.81. What is the difference between the Employment to population ratio(%) in Sub-Saharan Africa (developing only) in 2004 and the Employment to population ratio(%) in Peru in 2007?
Provide a succinct answer. -10.29. What is the difference between the Employment to population ratio(%) of Haiti in 2004 and the Employment to population ratio(%) of Peru in 2007?
Provide a succinct answer. -27.1. What is the difference between the Employment to population ratio(%) of Other small states in 2004 and the Employment to population ratio(%) of Sub-Saharan Africa (developing only) in 2008?
Your response must be concise. -8.59. What is the difference between the Employment to population ratio(%) of Other small states in 2004 and the Employment to population ratio(%) of Haiti in 2008?
Your answer should be very brief. 7.21. What is the difference between the Employment to population ratio(%) in Other small states in 2004 and the Employment to population ratio(%) in Peru in 2008?
Your answer should be very brief. -21.89. What is the difference between the Employment to population ratio(%) in Sub-Saharan Africa (developing only) in 2004 and the Employment to population ratio(%) in Haiti in 2008?
Make the answer very short. 16.01. What is the difference between the Employment to population ratio(%) of Sub-Saharan Africa (developing only) in 2004 and the Employment to population ratio(%) of Peru in 2008?
Your response must be concise. -13.09. What is the difference between the Employment to population ratio(%) in Haiti in 2004 and the Employment to population ratio(%) in Peru in 2008?
Give a very brief answer. -29.9. What is the difference between the Employment to population ratio(%) of Other small states in 2005 and the Employment to population ratio(%) of Sub-Saharan Africa (developing only) in 2006?
Your answer should be compact. -8.79. What is the difference between the Employment to population ratio(%) of Other small states in 2005 and the Employment to population ratio(%) of Haiti in 2006?
Provide a succinct answer. 6.95. What is the difference between the Employment to population ratio(%) in Other small states in 2005 and the Employment to population ratio(%) in Peru in 2006?
Offer a very short reply. -15.15. What is the difference between the Employment to population ratio(%) of Sub-Saharan Africa (developing only) in 2005 and the Employment to population ratio(%) of Haiti in 2006?
Keep it short and to the point. 16.16. What is the difference between the Employment to population ratio(%) in Sub-Saharan Africa (developing only) in 2005 and the Employment to population ratio(%) in Peru in 2006?
Provide a succinct answer. -5.94. What is the difference between the Employment to population ratio(%) in Haiti in 2005 and the Employment to population ratio(%) in Peru in 2006?
Give a very brief answer. -22.2. What is the difference between the Employment to population ratio(%) of Other small states in 2005 and the Employment to population ratio(%) of Sub-Saharan Africa (developing only) in 2007?
Your response must be concise. -8.95. What is the difference between the Employment to population ratio(%) of Other small states in 2005 and the Employment to population ratio(%) of Haiti in 2007?
Make the answer very short. 6.85. What is the difference between the Employment to population ratio(%) in Other small states in 2005 and the Employment to population ratio(%) in Peru in 2007?
Your answer should be very brief. -19.25. What is the difference between the Employment to population ratio(%) in Sub-Saharan Africa (developing only) in 2005 and the Employment to population ratio(%) in Haiti in 2007?
Your answer should be compact. 16.06. What is the difference between the Employment to population ratio(%) of Sub-Saharan Africa (developing only) in 2005 and the Employment to population ratio(%) of Peru in 2007?
Your response must be concise. -10.04. What is the difference between the Employment to population ratio(%) of Haiti in 2005 and the Employment to population ratio(%) of Peru in 2007?
Offer a very short reply. -26.3. What is the difference between the Employment to population ratio(%) of Other small states in 2005 and the Employment to population ratio(%) of Sub-Saharan Africa (developing only) in 2008?
Keep it short and to the point. -8.75. What is the difference between the Employment to population ratio(%) in Other small states in 2005 and the Employment to population ratio(%) in Haiti in 2008?
Provide a short and direct response. 7.05. What is the difference between the Employment to population ratio(%) in Other small states in 2005 and the Employment to population ratio(%) in Peru in 2008?
Keep it short and to the point. -22.05. What is the difference between the Employment to population ratio(%) in Sub-Saharan Africa (developing only) in 2005 and the Employment to population ratio(%) in Haiti in 2008?
Your answer should be compact. 16.26. What is the difference between the Employment to population ratio(%) of Sub-Saharan Africa (developing only) in 2005 and the Employment to population ratio(%) of Peru in 2008?
Ensure brevity in your answer.  -12.84. What is the difference between the Employment to population ratio(%) of Haiti in 2005 and the Employment to population ratio(%) of Peru in 2008?
Your answer should be compact. -29.1. What is the difference between the Employment to population ratio(%) in Other small states in 2006 and the Employment to population ratio(%) in Sub-Saharan Africa (developing only) in 2007?
Offer a very short reply. -8.66. What is the difference between the Employment to population ratio(%) in Other small states in 2006 and the Employment to population ratio(%) in Haiti in 2007?
Offer a very short reply. 7.15. What is the difference between the Employment to population ratio(%) of Other small states in 2006 and the Employment to population ratio(%) of Peru in 2007?
Your answer should be very brief. -18.95. What is the difference between the Employment to population ratio(%) in Sub-Saharan Africa (developing only) in 2006 and the Employment to population ratio(%) in Haiti in 2007?
Your response must be concise. 15.65. What is the difference between the Employment to population ratio(%) of Sub-Saharan Africa (developing only) in 2006 and the Employment to population ratio(%) of Peru in 2007?
Your answer should be compact. -10.45. What is the difference between the Employment to population ratio(%) in Haiti in 2006 and the Employment to population ratio(%) in Peru in 2007?
Provide a short and direct response. -26.2. What is the difference between the Employment to population ratio(%) in Other small states in 2006 and the Employment to population ratio(%) in Sub-Saharan Africa (developing only) in 2008?
Your answer should be compact. -8.46. What is the difference between the Employment to population ratio(%) in Other small states in 2006 and the Employment to population ratio(%) in Haiti in 2008?
Ensure brevity in your answer.  7.35. What is the difference between the Employment to population ratio(%) of Other small states in 2006 and the Employment to population ratio(%) of Peru in 2008?
Give a very brief answer. -21.75. What is the difference between the Employment to population ratio(%) in Sub-Saharan Africa (developing only) in 2006 and the Employment to population ratio(%) in Haiti in 2008?
Your response must be concise. 15.85. What is the difference between the Employment to population ratio(%) of Sub-Saharan Africa (developing only) in 2006 and the Employment to population ratio(%) of Peru in 2008?
Offer a terse response. -13.25. What is the difference between the Employment to population ratio(%) in Other small states in 2007 and the Employment to population ratio(%) in Sub-Saharan Africa (developing only) in 2008?
Provide a short and direct response. -8.27. What is the difference between the Employment to population ratio(%) in Other small states in 2007 and the Employment to population ratio(%) in Haiti in 2008?
Provide a short and direct response. 7.53. What is the difference between the Employment to population ratio(%) in Other small states in 2007 and the Employment to population ratio(%) in Peru in 2008?
Provide a short and direct response. -21.57. What is the difference between the Employment to population ratio(%) in Sub-Saharan Africa (developing only) in 2007 and the Employment to population ratio(%) in Haiti in 2008?
Your answer should be compact. 16.01. What is the difference between the Employment to population ratio(%) of Sub-Saharan Africa (developing only) in 2007 and the Employment to population ratio(%) of Peru in 2008?
Your answer should be compact. -13.09. What is the difference between the Employment to population ratio(%) of Haiti in 2007 and the Employment to population ratio(%) of Peru in 2008?
Ensure brevity in your answer.  -28.9. What is the average Employment to population ratio(%) of Other small states per year?
Your answer should be compact. 40.86. What is the average Employment to population ratio(%) of Sub-Saharan Africa (developing only) per year?
Make the answer very short. 49.4. What is the average Employment to population ratio(%) in Haiti per year?
Provide a short and direct response. 32.89. What is the average Employment to population ratio(%) of Peru per year?
Ensure brevity in your answer.  54.75. In the year 2001, what is the difference between the Employment to population ratio(%) of Other small states and Employment to population ratio(%) of Sub-Saharan Africa (developing only)?
Ensure brevity in your answer.  -7.96. In the year 2001, what is the difference between the Employment to population ratio(%) in Other small states and Employment to population ratio(%) in Haiti?
Your answer should be very brief. 9.69. In the year 2001, what is the difference between the Employment to population ratio(%) in Other small states and Employment to population ratio(%) in Peru?
Your response must be concise. -18.71. In the year 2001, what is the difference between the Employment to population ratio(%) of Sub-Saharan Africa (developing only) and Employment to population ratio(%) of Haiti?
Provide a short and direct response. 17.65. In the year 2001, what is the difference between the Employment to population ratio(%) of Sub-Saharan Africa (developing only) and Employment to population ratio(%) of Peru?
Offer a terse response. -10.75. In the year 2001, what is the difference between the Employment to population ratio(%) of Haiti and Employment to population ratio(%) of Peru?
Make the answer very short. -28.4. In the year 2002, what is the difference between the Employment to population ratio(%) in Other small states and Employment to population ratio(%) in Sub-Saharan Africa (developing only)?
Make the answer very short. -6.65. In the year 2002, what is the difference between the Employment to population ratio(%) of Other small states and Employment to population ratio(%) of Haiti?
Your answer should be very brief. 10.63. In the year 2002, what is the difference between the Employment to population ratio(%) in Other small states and Employment to population ratio(%) in Peru?
Provide a short and direct response. -11.07. In the year 2002, what is the difference between the Employment to population ratio(%) in Sub-Saharan Africa (developing only) and Employment to population ratio(%) in Haiti?
Offer a terse response. 17.28. In the year 2002, what is the difference between the Employment to population ratio(%) in Sub-Saharan Africa (developing only) and Employment to population ratio(%) in Peru?
Provide a succinct answer. -4.42. In the year 2002, what is the difference between the Employment to population ratio(%) of Haiti and Employment to population ratio(%) of Peru?
Offer a terse response. -21.7. In the year 2003, what is the difference between the Employment to population ratio(%) of Other small states and Employment to population ratio(%) of Sub-Saharan Africa (developing only)?
Offer a very short reply. -8.3. In the year 2003, what is the difference between the Employment to population ratio(%) in Other small states and Employment to population ratio(%) in Haiti?
Offer a very short reply. 8.4. In the year 2003, what is the difference between the Employment to population ratio(%) of Other small states and Employment to population ratio(%) of Peru?
Your answer should be very brief. -7. In the year 2003, what is the difference between the Employment to population ratio(%) of Sub-Saharan Africa (developing only) and Employment to population ratio(%) of Haiti?
Give a very brief answer. 16.7. In the year 2003, what is the difference between the Employment to population ratio(%) of Sub-Saharan Africa (developing only) and Employment to population ratio(%) of Peru?
Offer a very short reply. 1.3. In the year 2003, what is the difference between the Employment to population ratio(%) in Haiti and Employment to population ratio(%) in Peru?
Keep it short and to the point. -15.4. In the year 2004, what is the difference between the Employment to population ratio(%) in Other small states and Employment to population ratio(%) in Sub-Saharan Africa (developing only)?
Make the answer very short. -8.8. In the year 2004, what is the difference between the Employment to population ratio(%) of Other small states and Employment to population ratio(%) of Haiti?
Your answer should be compact. 8.01. In the year 2004, what is the difference between the Employment to population ratio(%) in Other small states and Employment to population ratio(%) in Peru?
Your answer should be very brief. -8.09. In the year 2004, what is the difference between the Employment to population ratio(%) of Sub-Saharan Africa (developing only) and Employment to population ratio(%) of Haiti?
Your response must be concise. 16.81. In the year 2004, what is the difference between the Employment to population ratio(%) of Sub-Saharan Africa (developing only) and Employment to population ratio(%) of Peru?
Offer a very short reply. 0.71. In the year 2004, what is the difference between the Employment to population ratio(%) in Haiti and Employment to population ratio(%) in Peru?
Offer a terse response. -16.1. In the year 2005, what is the difference between the Employment to population ratio(%) in Other small states and Employment to population ratio(%) in Sub-Saharan Africa (developing only)?
Keep it short and to the point. -9.2. In the year 2005, what is the difference between the Employment to population ratio(%) of Other small states and Employment to population ratio(%) of Haiti?
Make the answer very short. 7.05. In the year 2005, what is the difference between the Employment to population ratio(%) in Other small states and Employment to population ratio(%) in Peru?
Provide a succinct answer. -8.95. In the year 2005, what is the difference between the Employment to population ratio(%) in Sub-Saharan Africa (developing only) and Employment to population ratio(%) in Haiti?
Your response must be concise. 16.26. In the year 2005, what is the difference between the Employment to population ratio(%) of Sub-Saharan Africa (developing only) and Employment to population ratio(%) of Peru?
Give a very brief answer. 0.26. In the year 2005, what is the difference between the Employment to population ratio(%) in Haiti and Employment to population ratio(%) in Peru?
Make the answer very short. -16. In the year 2006, what is the difference between the Employment to population ratio(%) in Other small states and Employment to population ratio(%) in Sub-Saharan Africa (developing only)?
Your answer should be very brief. -8.5. In the year 2006, what is the difference between the Employment to population ratio(%) of Other small states and Employment to population ratio(%) of Haiti?
Offer a very short reply. 7.25. In the year 2006, what is the difference between the Employment to population ratio(%) in Other small states and Employment to population ratio(%) in Peru?
Provide a short and direct response. -14.85. In the year 2006, what is the difference between the Employment to population ratio(%) in Sub-Saharan Africa (developing only) and Employment to population ratio(%) in Haiti?
Your answer should be compact. 15.75. In the year 2006, what is the difference between the Employment to population ratio(%) in Sub-Saharan Africa (developing only) and Employment to population ratio(%) in Peru?
Provide a short and direct response. -6.35. In the year 2006, what is the difference between the Employment to population ratio(%) of Haiti and Employment to population ratio(%) of Peru?
Your answer should be compact. -22.1. In the year 2007, what is the difference between the Employment to population ratio(%) in Other small states and Employment to population ratio(%) in Sub-Saharan Africa (developing only)?
Give a very brief answer. -8.47. In the year 2007, what is the difference between the Employment to population ratio(%) of Other small states and Employment to population ratio(%) of Haiti?
Offer a terse response. 7.33. In the year 2007, what is the difference between the Employment to population ratio(%) in Other small states and Employment to population ratio(%) in Peru?
Your response must be concise. -18.77. In the year 2007, what is the difference between the Employment to population ratio(%) of Sub-Saharan Africa (developing only) and Employment to population ratio(%) of Haiti?
Keep it short and to the point. 15.81. In the year 2007, what is the difference between the Employment to population ratio(%) of Sub-Saharan Africa (developing only) and Employment to population ratio(%) of Peru?
Offer a very short reply. -10.29. In the year 2007, what is the difference between the Employment to population ratio(%) in Haiti and Employment to population ratio(%) in Peru?
Keep it short and to the point. -26.1. In the year 2008, what is the difference between the Employment to population ratio(%) in Other small states and Employment to population ratio(%) in Sub-Saharan Africa (developing only)?
Ensure brevity in your answer.  -10.36. In the year 2008, what is the difference between the Employment to population ratio(%) of Other small states and Employment to population ratio(%) of Haiti?
Ensure brevity in your answer.  5.45. In the year 2008, what is the difference between the Employment to population ratio(%) in Other small states and Employment to population ratio(%) in Peru?
Your answer should be compact. -23.65. In the year 2008, what is the difference between the Employment to population ratio(%) in Sub-Saharan Africa (developing only) and Employment to population ratio(%) in Haiti?
Your answer should be compact. 15.81. In the year 2008, what is the difference between the Employment to population ratio(%) of Sub-Saharan Africa (developing only) and Employment to population ratio(%) of Peru?
Ensure brevity in your answer.  -13.29. In the year 2008, what is the difference between the Employment to population ratio(%) of Haiti and Employment to population ratio(%) of Peru?
Offer a very short reply. -29.1. What is the ratio of the Employment to population ratio(%) of Other small states in 2001 to that in 2002?
Offer a very short reply. 0.97. What is the ratio of the Employment to population ratio(%) in Haiti in 2001 to that in 2002?
Give a very brief answer. 0.99. What is the ratio of the Employment to population ratio(%) of Peru in 2001 to that in 2002?
Your answer should be compact. 1.12. What is the ratio of the Employment to population ratio(%) in Other small states in 2001 to that in 2003?
Provide a short and direct response. 1.01. What is the ratio of the Employment to population ratio(%) of Haiti in 2001 to that in 2003?
Your answer should be compact. 0.98. What is the ratio of the Employment to population ratio(%) of Peru in 2001 to that in 2003?
Give a very brief answer. 1.25. What is the ratio of the Employment to population ratio(%) in Other small states in 2001 to that in 2004?
Your answer should be compact. 1.02. What is the ratio of the Employment to population ratio(%) in Sub-Saharan Africa (developing only) in 2001 to that in 2004?
Make the answer very short. 1. What is the ratio of the Employment to population ratio(%) of Haiti in 2001 to that in 2004?
Make the answer very short. 0.98. What is the ratio of the Employment to population ratio(%) in Peru in 2001 to that in 2004?
Keep it short and to the point. 1.24. What is the ratio of the Employment to population ratio(%) in Other small states in 2001 to that in 2005?
Ensure brevity in your answer.  1.03. What is the ratio of the Employment to population ratio(%) of Sub-Saharan Africa (developing only) in 2001 to that in 2005?
Keep it short and to the point. 1. What is the ratio of the Employment to population ratio(%) in Haiti in 2001 to that in 2005?
Give a very brief answer. 0.95. What is the ratio of the Employment to population ratio(%) in Peru in 2001 to that in 2005?
Give a very brief answer. 1.22. What is the ratio of the Employment to population ratio(%) of Other small states in 2001 to that in 2006?
Provide a short and direct response. 1.02. What is the ratio of the Employment to population ratio(%) in Haiti in 2001 to that in 2006?
Provide a succinct answer. 0.95. What is the ratio of the Employment to population ratio(%) of Peru in 2001 to that in 2006?
Give a very brief answer. 1.08. What is the ratio of the Employment to population ratio(%) of Other small states in 2001 to that in 2007?
Your response must be concise. 1.01. What is the ratio of the Employment to population ratio(%) of Sub-Saharan Africa (developing only) in 2001 to that in 2007?
Give a very brief answer. 1. What is the ratio of the Employment to population ratio(%) of Haiti in 2001 to that in 2007?
Offer a very short reply. 0.95. What is the ratio of the Employment to population ratio(%) in Peru in 2001 to that in 2007?
Give a very brief answer. 1.01. What is the ratio of the Employment to population ratio(%) of Other small states in 2001 to that in 2008?
Your answer should be very brief. 1.07. What is the ratio of the Employment to population ratio(%) of Sub-Saharan Africa (developing only) in 2001 to that in 2008?
Your answer should be compact. 1. What is the ratio of the Employment to population ratio(%) in Haiti in 2001 to that in 2008?
Provide a succinct answer. 0.95. What is the ratio of the Employment to population ratio(%) of Peru in 2001 to that in 2008?
Your answer should be very brief. 0.96. What is the ratio of the Employment to population ratio(%) of Other small states in 2002 to that in 2003?
Make the answer very short. 1.04. What is the ratio of the Employment to population ratio(%) of Haiti in 2002 to that in 2003?
Provide a short and direct response. 0.99. What is the ratio of the Employment to population ratio(%) of Peru in 2002 to that in 2003?
Offer a terse response. 1.12. What is the ratio of the Employment to population ratio(%) of Other small states in 2002 to that in 2004?
Keep it short and to the point. 1.05. What is the ratio of the Employment to population ratio(%) of Sub-Saharan Africa (developing only) in 2002 to that in 2004?
Ensure brevity in your answer.  1. What is the ratio of the Employment to population ratio(%) in Haiti in 2002 to that in 2004?
Provide a succinct answer. 0.99. What is the ratio of the Employment to population ratio(%) of Peru in 2002 to that in 2004?
Your answer should be compact. 1.11. What is the ratio of the Employment to population ratio(%) of Other small states in 2002 to that in 2005?
Your answer should be very brief. 1.06. What is the ratio of the Employment to population ratio(%) of Haiti in 2002 to that in 2005?
Offer a very short reply. 0.96. What is the ratio of the Employment to population ratio(%) in Peru in 2002 to that in 2005?
Offer a terse response. 1.09. What is the ratio of the Employment to population ratio(%) in Other small states in 2002 to that in 2006?
Your response must be concise. 1.05. What is the ratio of the Employment to population ratio(%) of Haiti in 2002 to that in 2006?
Ensure brevity in your answer.  0.96. What is the ratio of the Employment to population ratio(%) in Peru in 2002 to that in 2006?
Give a very brief answer. 0.97. What is the ratio of the Employment to population ratio(%) of Other small states in 2002 to that in 2007?
Offer a very short reply. 1.05. What is the ratio of the Employment to population ratio(%) of Sub-Saharan Africa (developing only) in 2002 to that in 2007?
Offer a very short reply. 1. What is the ratio of the Employment to population ratio(%) in Peru in 2002 to that in 2007?
Provide a succinct answer. 0.9. What is the ratio of the Employment to population ratio(%) in Other small states in 2002 to that in 2008?
Provide a short and direct response. 1.1. What is the ratio of the Employment to population ratio(%) in Haiti in 2002 to that in 2008?
Your answer should be very brief. 0.96. What is the ratio of the Employment to population ratio(%) in Peru in 2002 to that in 2008?
Keep it short and to the point. 0.86. What is the ratio of the Employment to population ratio(%) of Other small states in 2003 to that in 2004?
Offer a very short reply. 1.01. What is the ratio of the Employment to population ratio(%) in Sub-Saharan Africa (developing only) in 2003 to that in 2004?
Ensure brevity in your answer.  1. What is the ratio of the Employment to population ratio(%) of Haiti in 2003 to that in 2004?
Your answer should be very brief. 1. What is the ratio of the Employment to population ratio(%) of Peru in 2003 to that in 2004?
Ensure brevity in your answer.  0.99. What is the ratio of the Employment to population ratio(%) of Other small states in 2003 to that in 2005?
Offer a terse response. 1.01. What is the ratio of the Employment to population ratio(%) of Sub-Saharan Africa (developing only) in 2003 to that in 2005?
Offer a terse response. 0.99. What is the ratio of the Employment to population ratio(%) in Haiti in 2003 to that in 2005?
Keep it short and to the point. 0.98. What is the ratio of the Employment to population ratio(%) of Peru in 2003 to that in 2005?
Offer a very short reply. 0.97. What is the ratio of the Employment to population ratio(%) in Sub-Saharan Africa (developing only) in 2003 to that in 2006?
Keep it short and to the point. 1. What is the ratio of the Employment to population ratio(%) in Haiti in 2003 to that in 2006?
Your answer should be very brief. 0.97. What is the ratio of the Employment to population ratio(%) of Peru in 2003 to that in 2006?
Make the answer very short. 0.86. What is the ratio of the Employment to population ratio(%) of Haiti in 2003 to that in 2007?
Offer a very short reply. 0.97. What is the ratio of the Employment to population ratio(%) of Peru in 2003 to that in 2007?
Provide a short and direct response. 0.8. What is the ratio of the Employment to population ratio(%) of Other small states in 2003 to that in 2008?
Offer a terse response. 1.06. What is the ratio of the Employment to population ratio(%) in Sub-Saharan Africa (developing only) in 2003 to that in 2008?
Your response must be concise. 1. What is the ratio of the Employment to population ratio(%) in Peru in 2003 to that in 2008?
Ensure brevity in your answer.  0.77. What is the ratio of the Employment to population ratio(%) in Other small states in 2004 to that in 2005?
Give a very brief answer. 1. What is the ratio of the Employment to population ratio(%) in Sub-Saharan Africa (developing only) in 2004 to that in 2005?
Offer a very short reply. 0.99. What is the ratio of the Employment to population ratio(%) of Haiti in 2004 to that in 2005?
Provide a succinct answer. 0.98. What is the ratio of the Employment to population ratio(%) in Peru in 2004 to that in 2005?
Give a very brief answer. 0.99. What is the ratio of the Employment to population ratio(%) of Sub-Saharan Africa (developing only) in 2004 to that in 2006?
Make the answer very short. 1. What is the ratio of the Employment to population ratio(%) of Haiti in 2004 to that in 2006?
Your response must be concise. 0.97. What is the ratio of the Employment to population ratio(%) of Peru in 2004 to that in 2006?
Your response must be concise. 0.88. What is the ratio of the Employment to population ratio(%) in Other small states in 2004 to that in 2007?
Give a very brief answer. 0.99. What is the ratio of the Employment to population ratio(%) in Haiti in 2004 to that in 2007?
Ensure brevity in your answer.  0.97. What is the ratio of the Employment to population ratio(%) of Peru in 2004 to that in 2007?
Ensure brevity in your answer.  0.82. What is the ratio of the Employment to population ratio(%) of Other small states in 2004 to that in 2008?
Keep it short and to the point. 1.05. What is the ratio of the Employment to population ratio(%) in Haiti in 2004 to that in 2008?
Keep it short and to the point. 0.98. What is the ratio of the Employment to population ratio(%) of Peru in 2004 to that in 2008?
Your answer should be very brief. 0.78. What is the ratio of the Employment to population ratio(%) in Sub-Saharan Africa (developing only) in 2005 to that in 2006?
Your response must be concise. 1.01. What is the ratio of the Employment to population ratio(%) in Haiti in 2005 to that in 2006?
Provide a short and direct response. 1. What is the ratio of the Employment to population ratio(%) in Peru in 2005 to that in 2006?
Offer a very short reply. 0.89. What is the ratio of the Employment to population ratio(%) of Other small states in 2005 to that in 2007?
Keep it short and to the point. 0.99. What is the ratio of the Employment to population ratio(%) of Sub-Saharan Africa (developing only) in 2005 to that in 2007?
Provide a short and direct response. 1.01. What is the ratio of the Employment to population ratio(%) of Peru in 2005 to that in 2007?
Offer a very short reply. 0.83. What is the ratio of the Employment to population ratio(%) of Other small states in 2005 to that in 2008?
Offer a terse response. 1.04. What is the ratio of the Employment to population ratio(%) of Sub-Saharan Africa (developing only) in 2005 to that in 2008?
Make the answer very short. 1.01. What is the ratio of the Employment to population ratio(%) of Peru in 2005 to that in 2008?
Keep it short and to the point. 0.79. What is the ratio of the Employment to population ratio(%) of Other small states in 2006 to that in 2007?
Make the answer very short. 1. What is the ratio of the Employment to population ratio(%) of Haiti in 2006 to that in 2007?
Provide a short and direct response. 1. What is the ratio of the Employment to population ratio(%) in Peru in 2006 to that in 2007?
Your response must be concise. 0.93. What is the ratio of the Employment to population ratio(%) in Other small states in 2006 to that in 2008?
Keep it short and to the point. 1.05. What is the ratio of the Employment to population ratio(%) in Sub-Saharan Africa (developing only) in 2006 to that in 2008?
Your answer should be very brief. 1. What is the ratio of the Employment to population ratio(%) in Peru in 2006 to that in 2008?
Provide a short and direct response. 0.89. What is the ratio of the Employment to population ratio(%) in Other small states in 2007 to that in 2008?
Offer a very short reply. 1.05. What is the ratio of the Employment to population ratio(%) of Sub-Saharan Africa (developing only) in 2007 to that in 2008?
Your response must be concise. 1. What is the ratio of the Employment to population ratio(%) of Peru in 2007 to that in 2008?
Your answer should be very brief. 0.96. What is the difference between the highest and the second highest Employment to population ratio(%) in Other small states?
Offer a terse response. 1.34. What is the difference between the highest and the second highest Employment to population ratio(%) of Sub-Saharan Africa (developing only)?
Your answer should be very brief. 0.18. What is the difference between the highest and the second highest Employment to population ratio(%) of Haiti?
Ensure brevity in your answer.  0.1. What is the difference between the highest and the lowest Employment to population ratio(%) in Other small states?
Offer a terse response. 3.98. What is the difference between the highest and the lowest Employment to population ratio(%) in Sub-Saharan Africa (developing only)?
Offer a very short reply. 0.45. What is the difference between the highest and the lowest Employment to population ratio(%) in Peru?
Your answer should be compact. 14.5. 